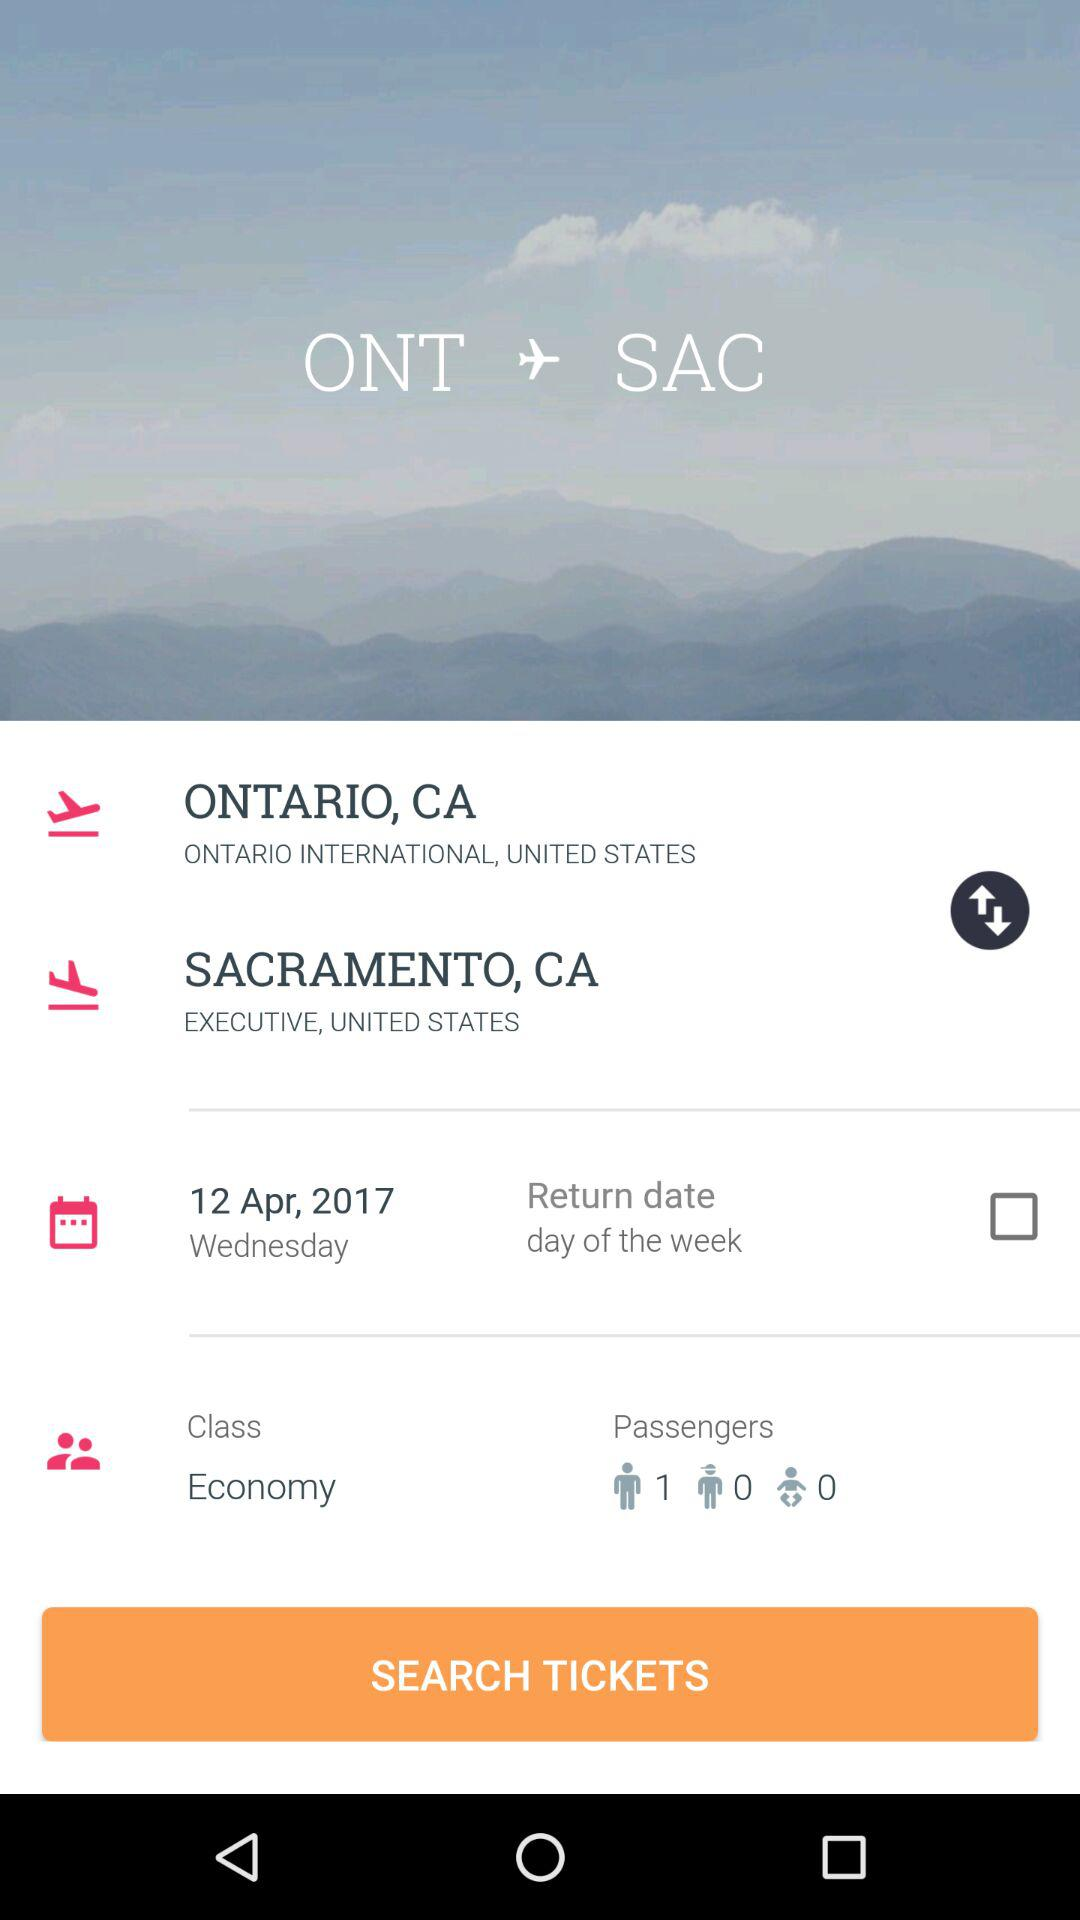How many passengers are there?
Answer the question using a single word or phrase. 1 